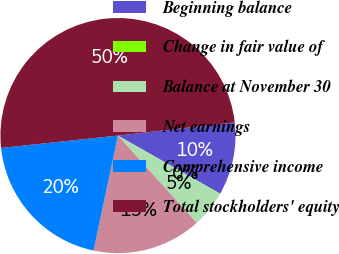Convert chart to OTSL. <chart><loc_0><loc_0><loc_500><loc_500><pie_chart><fcel>Beginning balance<fcel>Change in fair value of<fcel>Balance at November 30<fcel>Net earnings<fcel>Comprehensive income<fcel>Total stockholders' equity<nl><fcel>10.02%<fcel>0.05%<fcel>5.04%<fcel>15.01%<fcel>19.99%<fcel>49.89%<nl></chart> 